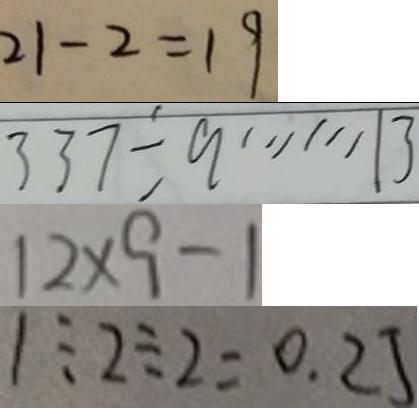<formula> <loc_0><loc_0><loc_500><loc_500>2 1 - 2 = 1 9 
 3 3 7 \div 9 \cdots 1 3 
 1 2 \times 9 - 1 
 1 \div 2 \div 2 = 0 . 2 5</formula> 